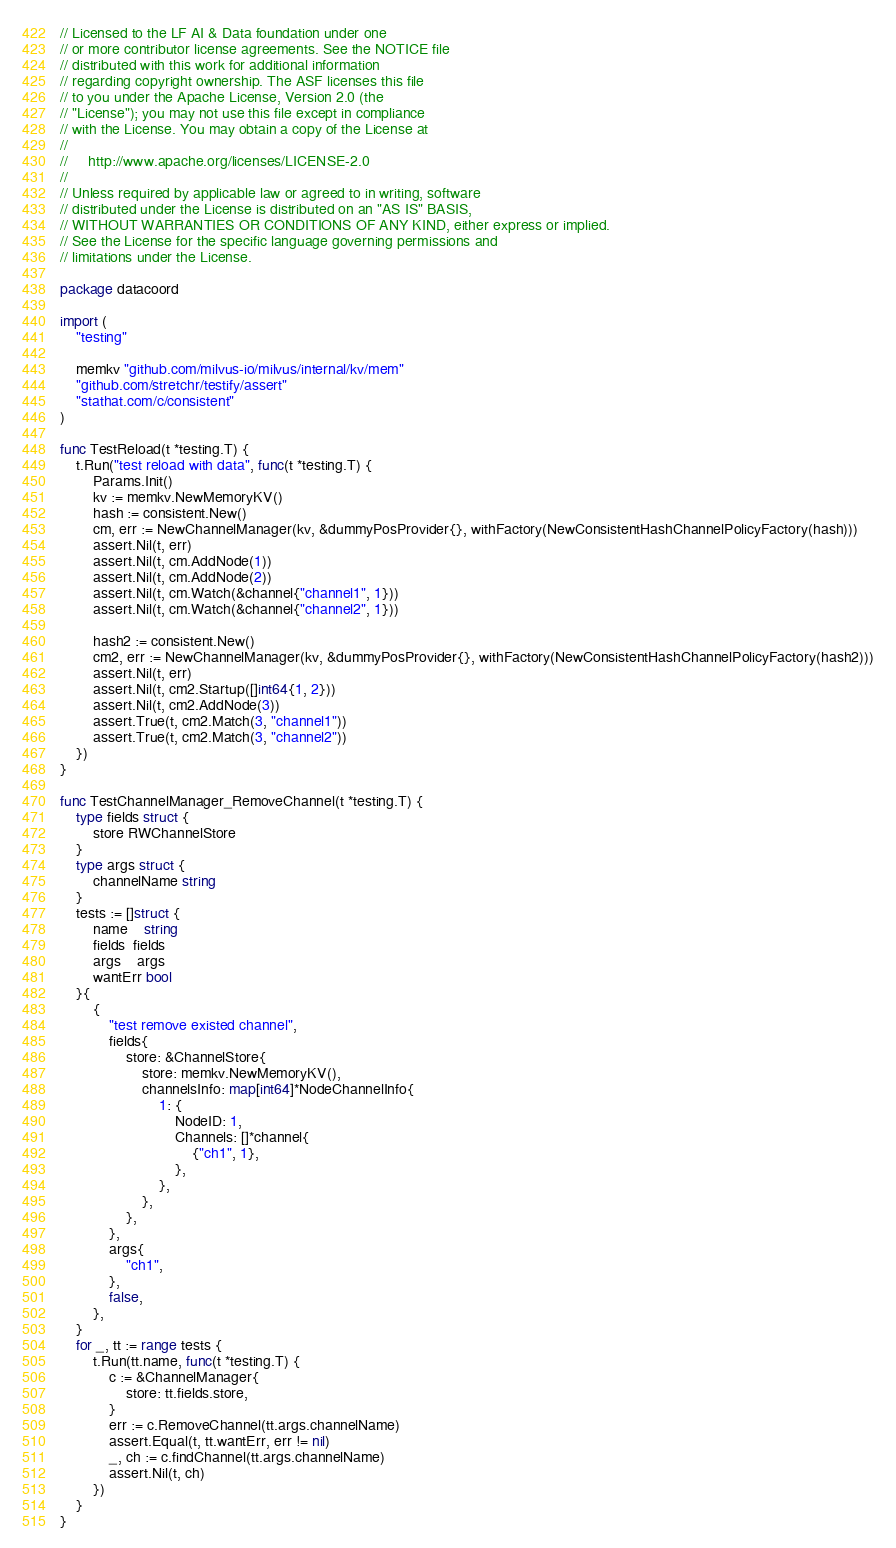<code> <loc_0><loc_0><loc_500><loc_500><_Go_>// Licensed to the LF AI & Data foundation under one
// or more contributor license agreements. See the NOTICE file
// distributed with this work for additional information
// regarding copyright ownership. The ASF licenses this file
// to you under the Apache License, Version 2.0 (the
// "License"); you may not use this file except in compliance
// with the License. You may obtain a copy of the License at
//
//     http://www.apache.org/licenses/LICENSE-2.0
//
// Unless required by applicable law or agreed to in writing, software
// distributed under the License is distributed on an "AS IS" BASIS,
// WITHOUT WARRANTIES OR CONDITIONS OF ANY KIND, either express or implied.
// See the License for the specific language governing permissions and
// limitations under the License.

package datacoord

import (
	"testing"

	memkv "github.com/milvus-io/milvus/internal/kv/mem"
	"github.com/stretchr/testify/assert"
	"stathat.com/c/consistent"
)

func TestReload(t *testing.T) {
	t.Run("test reload with data", func(t *testing.T) {
		Params.Init()
		kv := memkv.NewMemoryKV()
		hash := consistent.New()
		cm, err := NewChannelManager(kv, &dummyPosProvider{}, withFactory(NewConsistentHashChannelPolicyFactory(hash)))
		assert.Nil(t, err)
		assert.Nil(t, cm.AddNode(1))
		assert.Nil(t, cm.AddNode(2))
		assert.Nil(t, cm.Watch(&channel{"channel1", 1}))
		assert.Nil(t, cm.Watch(&channel{"channel2", 1}))

		hash2 := consistent.New()
		cm2, err := NewChannelManager(kv, &dummyPosProvider{}, withFactory(NewConsistentHashChannelPolicyFactory(hash2)))
		assert.Nil(t, err)
		assert.Nil(t, cm2.Startup([]int64{1, 2}))
		assert.Nil(t, cm2.AddNode(3))
		assert.True(t, cm2.Match(3, "channel1"))
		assert.True(t, cm2.Match(3, "channel2"))
	})
}

func TestChannelManager_RemoveChannel(t *testing.T) {
	type fields struct {
		store RWChannelStore
	}
	type args struct {
		channelName string
	}
	tests := []struct {
		name    string
		fields  fields
		args    args
		wantErr bool
	}{
		{
			"test remove existed channel",
			fields{
				store: &ChannelStore{
					store: memkv.NewMemoryKV(),
					channelsInfo: map[int64]*NodeChannelInfo{
						1: {
							NodeID: 1,
							Channels: []*channel{
								{"ch1", 1},
							},
						},
					},
				},
			},
			args{
				"ch1",
			},
			false,
		},
	}
	for _, tt := range tests {
		t.Run(tt.name, func(t *testing.T) {
			c := &ChannelManager{
				store: tt.fields.store,
			}
			err := c.RemoveChannel(tt.args.channelName)
			assert.Equal(t, tt.wantErr, err != nil)
			_, ch := c.findChannel(tt.args.channelName)
			assert.Nil(t, ch)
		})
	}
}
</code> 